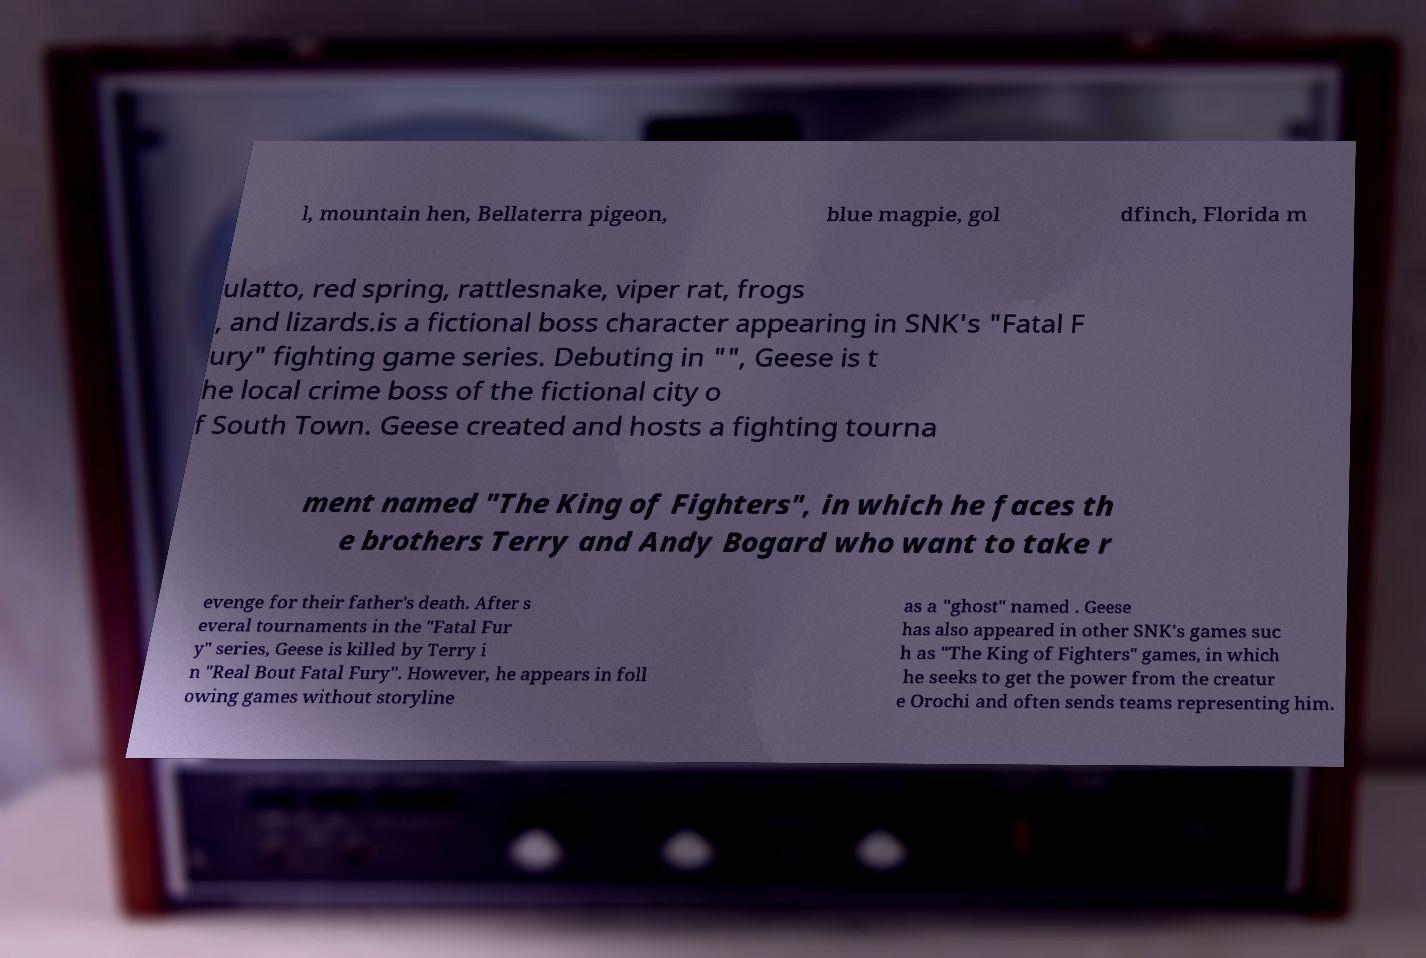Please read and relay the text visible in this image. What does it say? l, mountain hen, Bellaterra pigeon, blue magpie, gol dfinch, Florida m ulatto, red spring, rattlesnake, viper rat, frogs , and lizards.is a fictional boss character appearing in SNK's "Fatal F ury" fighting game series. Debuting in "", Geese is t he local crime boss of the fictional city o f South Town. Geese created and hosts a fighting tourna ment named "The King of Fighters", in which he faces th e brothers Terry and Andy Bogard who want to take r evenge for their father's death. After s everal tournaments in the "Fatal Fur y" series, Geese is killed by Terry i n "Real Bout Fatal Fury". However, he appears in foll owing games without storyline as a "ghost" named . Geese has also appeared in other SNK's games suc h as "The King of Fighters" games, in which he seeks to get the power from the creatur e Orochi and often sends teams representing him. 